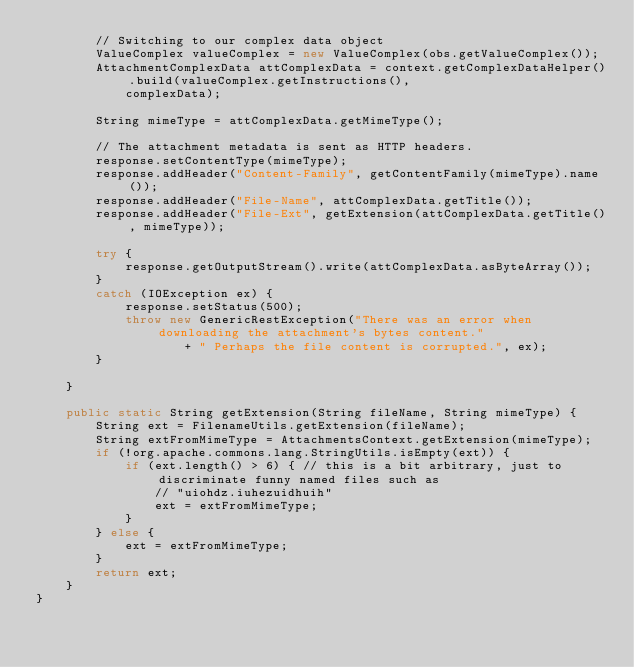Convert code to text. <code><loc_0><loc_0><loc_500><loc_500><_Java_>		// Switching to our complex data object
		ValueComplex valueComplex = new ValueComplex(obs.getValueComplex());
		AttachmentComplexData attComplexData = context.getComplexDataHelper().build(valueComplex.getInstructions(),
		    complexData);
		
		String mimeType = attComplexData.getMimeType();
		
		// The attachment metadata is sent as HTTP headers.
		response.setContentType(mimeType);
		response.addHeader("Content-Family", getContentFamily(mimeType).name());
		response.addHeader("File-Name", attComplexData.getTitle());
		response.addHeader("File-Ext", getExtension(attComplexData.getTitle(), mimeType));
		
		try {
			response.getOutputStream().write(attComplexData.asByteArray());
		}
		catch (IOException ex) {
			response.setStatus(500);
			throw new GenericRestException("There was an error when downloading the attachment's bytes content."
			        + " Perhaps the file content is corrupted.", ex);
		}
		
	}
	
	public static String getExtension(String fileName, String mimeType) {
		String ext = FilenameUtils.getExtension(fileName);
		String extFromMimeType = AttachmentsContext.getExtension(mimeType);
		if (!org.apache.commons.lang.StringUtils.isEmpty(ext)) {
			if (ext.length() > 6) { // this is a bit arbitrary, just to discriminate funny named files such as
				// "uiohdz.iuhezuidhuih"
				ext = extFromMimeType;
			}
		} else {
			ext = extFromMimeType;
		}
		return ext;
	}
}
</code> 